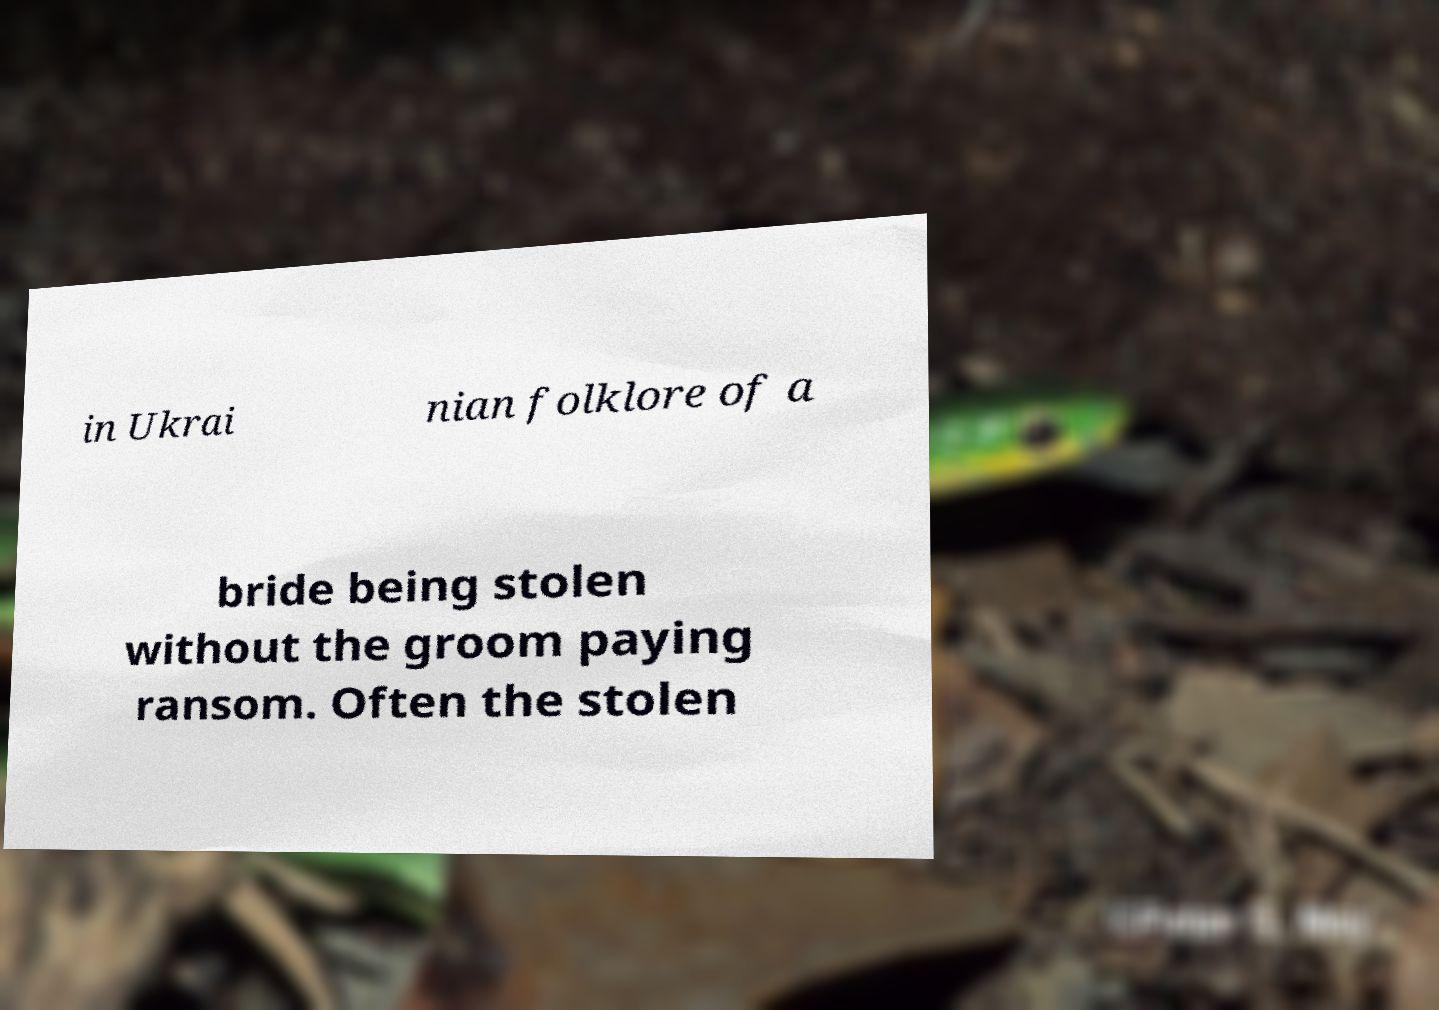Please identify and transcribe the text found in this image. in Ukrai nian folklore of a bride being stolen without the groom paying ransom. Often the stolen 